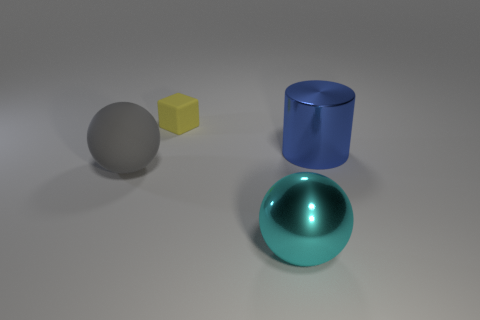What shape is the cyan metal thing that is the same size as the gray matte ball?
Provide a short and direct response. Sphere. How many rubber objects are big cyan balls or small yellow things?
Your answer should be compact. 1. Is the large sphere that is to the right of the cube made of the same material as the big ball that is to the left of the cyan ball?
Keep it short and to the point. No. There is a thing that is made of the same material as the cylinder; what is its color?
Make the answer very short. Cyan. Is the number of yellow blocks on the left side of the cyan metallic object greater than the number of big metallic cylinders that are in front of the large gray matte thing?
Provide a short and direct response. Yes. Are any big purple shiny blocks visible?
Give a very brief answer. No. How many things are either big blue objects or small cyan metallic blocks?
Provide a succinct answer. 1. There is a metal object that is behind the cyan sphere; what number of large cylinders are behind it?
Provide a short and direct response. 0. Is the number of large shiny objects greater than the number of yellow cubes?
Provide a short and direct response. Yes. Does the tiny yellow object have the same material as the big cyan thing?
Provide a succinct answer. No. 